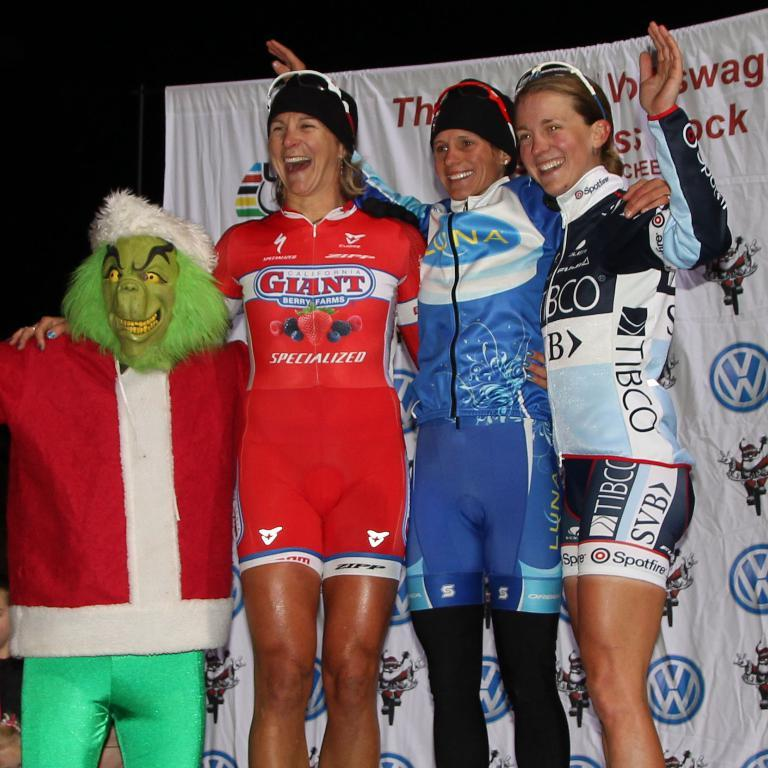<image>
Summarize the visual content of the image. Sponsor Giant Berry Farms have various berries on the red uniform. 